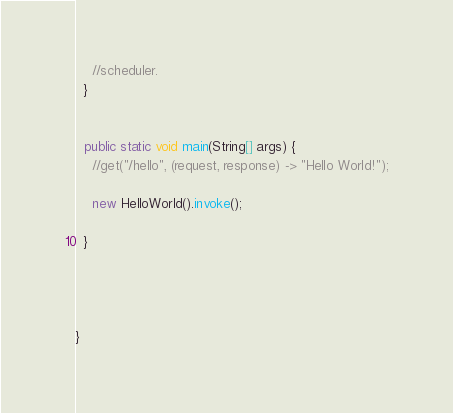<code> <loc_0><loc_0><loc_500><loc_500><_Java_>    //scheduler.
  }
  
  
  public static void main(String[] args) {
    //get("/hello", (request, response) -> "Hello World!");
    
    new HelloWorld().invoke();
    
  }
  
  
  
  
}
</code> 